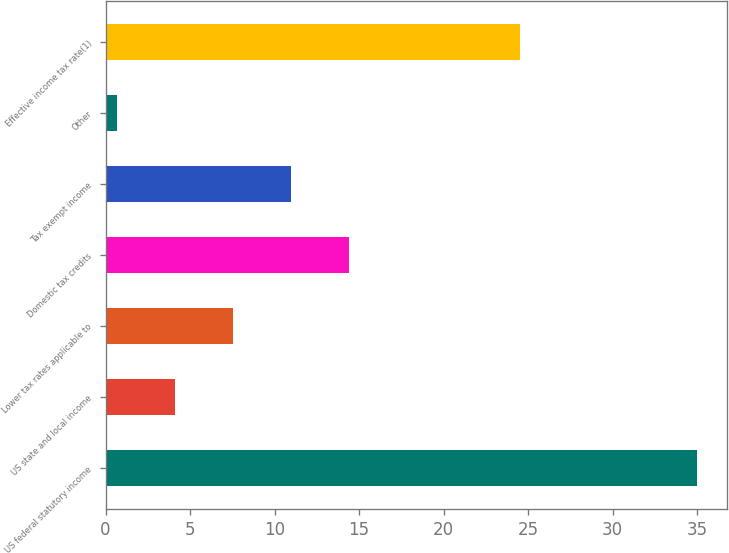Convert chart to OTSL. <chart><loc_0><loc_0><loc_500><loc_500><bar_chart><fcel>US federal statutory income<fcel>US state and local income<fcel>Lower tax rates applicable to<fcel>Domestic tax credits<fcel>Tax exempt income<fcel>Other<fcel>Effective income tax rate(1)<nl><fcel>35<fcel>4.13<fcel>7.56<fcel>14.42<fcel>10.99<fcel>0.7<fcel>24.5<nl></chart> 